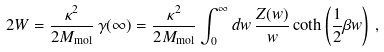Convert formula to latex. <formula><loc_0><loc_0><loc_500><loc_500>2 W = \frac { \kappa ^ { 2 } } { 2 M _ { \text {mol} } } \, \gamma ( \infty ) = \frac { \kappa ^ { 2 } } { 2 M _ { \text {mol} } } \int _ { 0 } ^ { \infty } d w \, \frac { Z ( w ) } { w } \coth \left ( \frac { 1 } { 2 } \beta w \right ) \, ,</formula> 